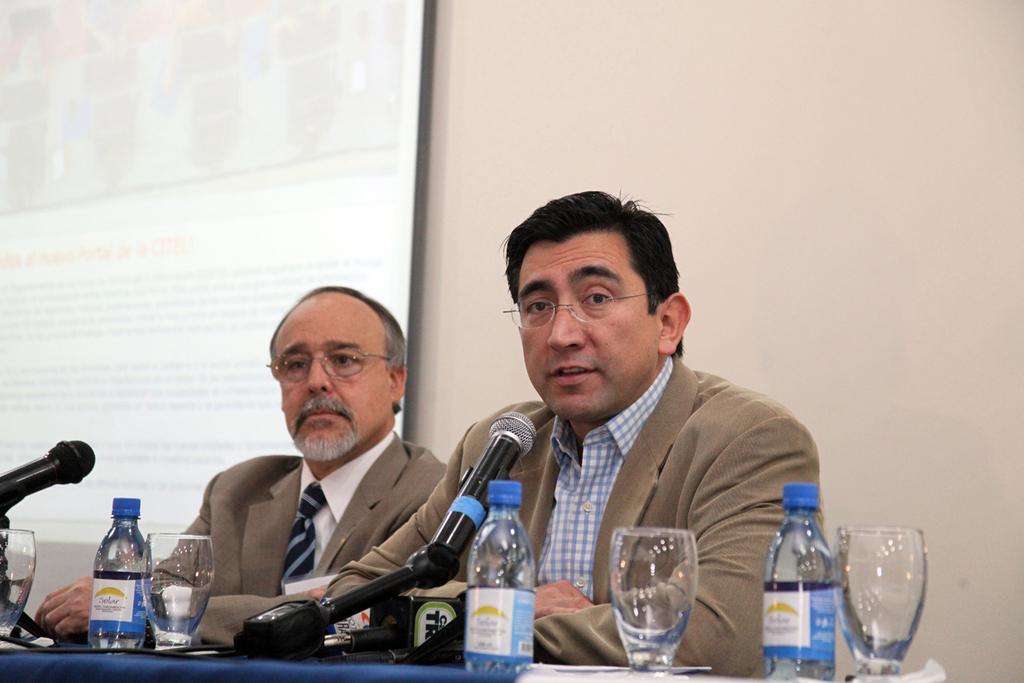Please provide a concise description of this image. This image consist of two men. They are sitting in a conference. Both are wearing brown suits. In front of them there is a table. On which there are bottles, glasses, and mics. In the background, there is a projector screen and wall. 